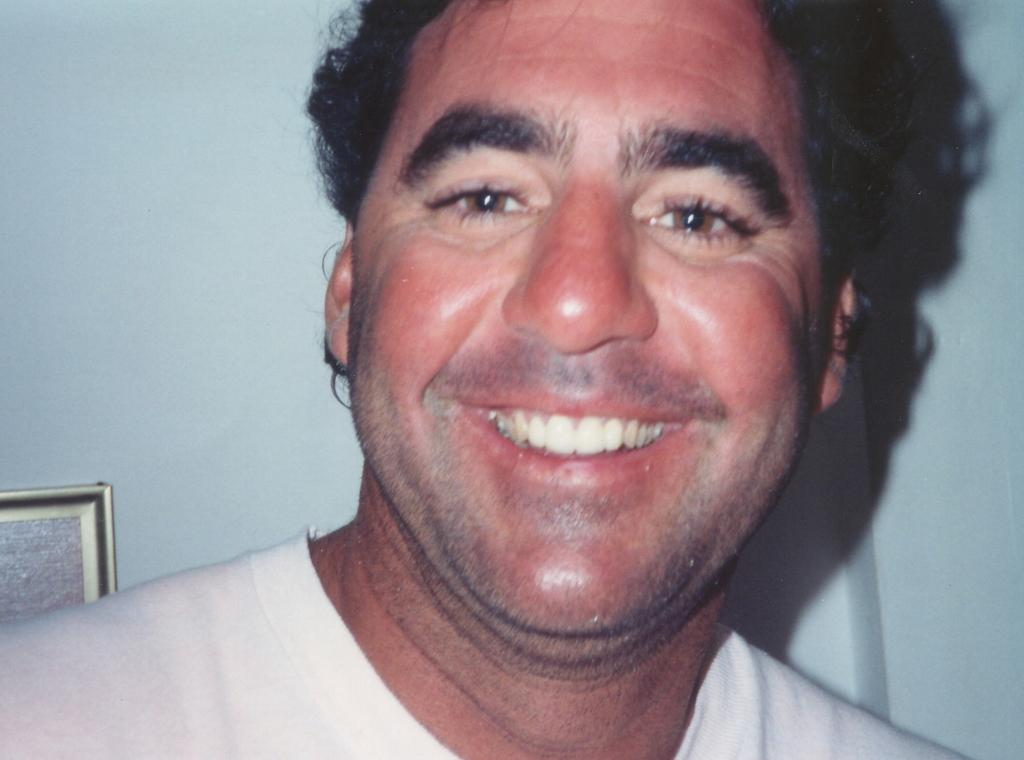Who or what is present in the image? There is a person in the image. What is the facial expression of the person? The person has a smiling face. What can be seen in the background of the image? There is a wall in the background of the image. What is hanging on the wall in the background? There is a photo frame on the wall in the background. What type of record is being played in the background of the image? There is no record being played in the image; it only features a person with a smiling face and a wall with a photo frame in the background. 